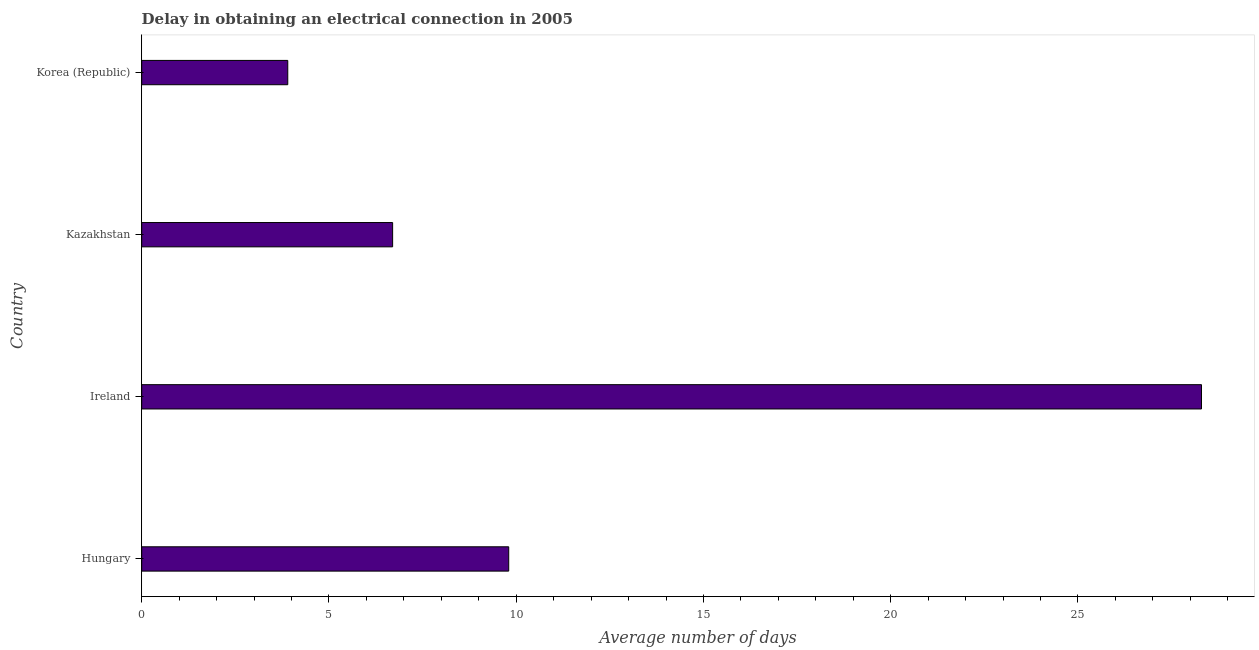Does the graph contain grids?
Your answer should be very brief. No. What is the title of the graph?
Offer a very short reply. Delay in obtaining an electrical connection in 2005. What is the label or title of the X-axis?
Make the answer very short. Average number of days. What is the label or title of the Y-axis?
Provide a short and direct response. Country. Across all countries, what is the maximum dalay in electrical connection?
Provide a succinct answer. 28.3. In which country was the dalay in electrical connection maximum?
Offer a very short reply. Ireland. In which country was the dalay in electrical connection minimum?
Provide a short and direct response. Korea (Republic). What is the sum of the dalay in electrical connection?
Ensure brevity in your answer.  48.7. What is the difference between the dalay in electrical connection in Hungary and Ireland?
Provide a short and direct response. -18.5. What is the average dalay in electrical connection per country?
Your answer should be very brief. 12.18. What is the median dalay in electrical connection?
Your response must be concise. 8.25. What is the ratio of the dalay in electrical connection in Kazakhstan to that in Korea (Republic)?
Offer a terse response. 1.72. Is the dalay in electrical connection in Hungary less than that in Korea (Republic)?
Provide a succinct answer. No. What is the difference between the highest and the lowest dalay in electrical connection?
Make the answer very short. 24.4. In how many countries, is the dalay in electrical connection greater than the average dalay in electrical connection taken over all countries?
Offer a terse response. 1. Are all the bars in the graph horizontal?
Provide a short and direct response. Yes. What is the Average number of days in Ireland?
Your response must be concise. 28.3. What is the Average number of days in Korea (Republic)?
Provide a short and direct response. 3.9. What is the difference between the Average number of days in Hungary and Ireland?
Ensure brevity in your answer.  -18.5. What is the difference between the Average number of days in Ireland and Kazakhstan?
Provide a short and direct response. 21.6. What is the difference between the Average number of days in Ireland and Korea (Republic)?
Give a very brief answer. 24.4. What is the ratio of the Average number of days in Hungary to that in Ireland?
Provide a short and direct response. 0.35. What is the ratio of the Average number of days in Hungary to that in Kazakhstan?
Make the answer very short. 1.46. What is the ratio of the Average number of days in Hungary to that in Korea (Republic)?
Your response must be concise. 2.51. What is the ratio of the Average number of days in Ireland to that in Kazakhstan?
Your response must be concise. 4.22. What is the ratio of the Average number of days in Ireland to that in Korea (Republic)?
Your answer should be compact. 7.26. What is the ratio of the Average number of days in Kazakhstan to that in Korea (Republic)?
Your response must be concise. 1.72. 